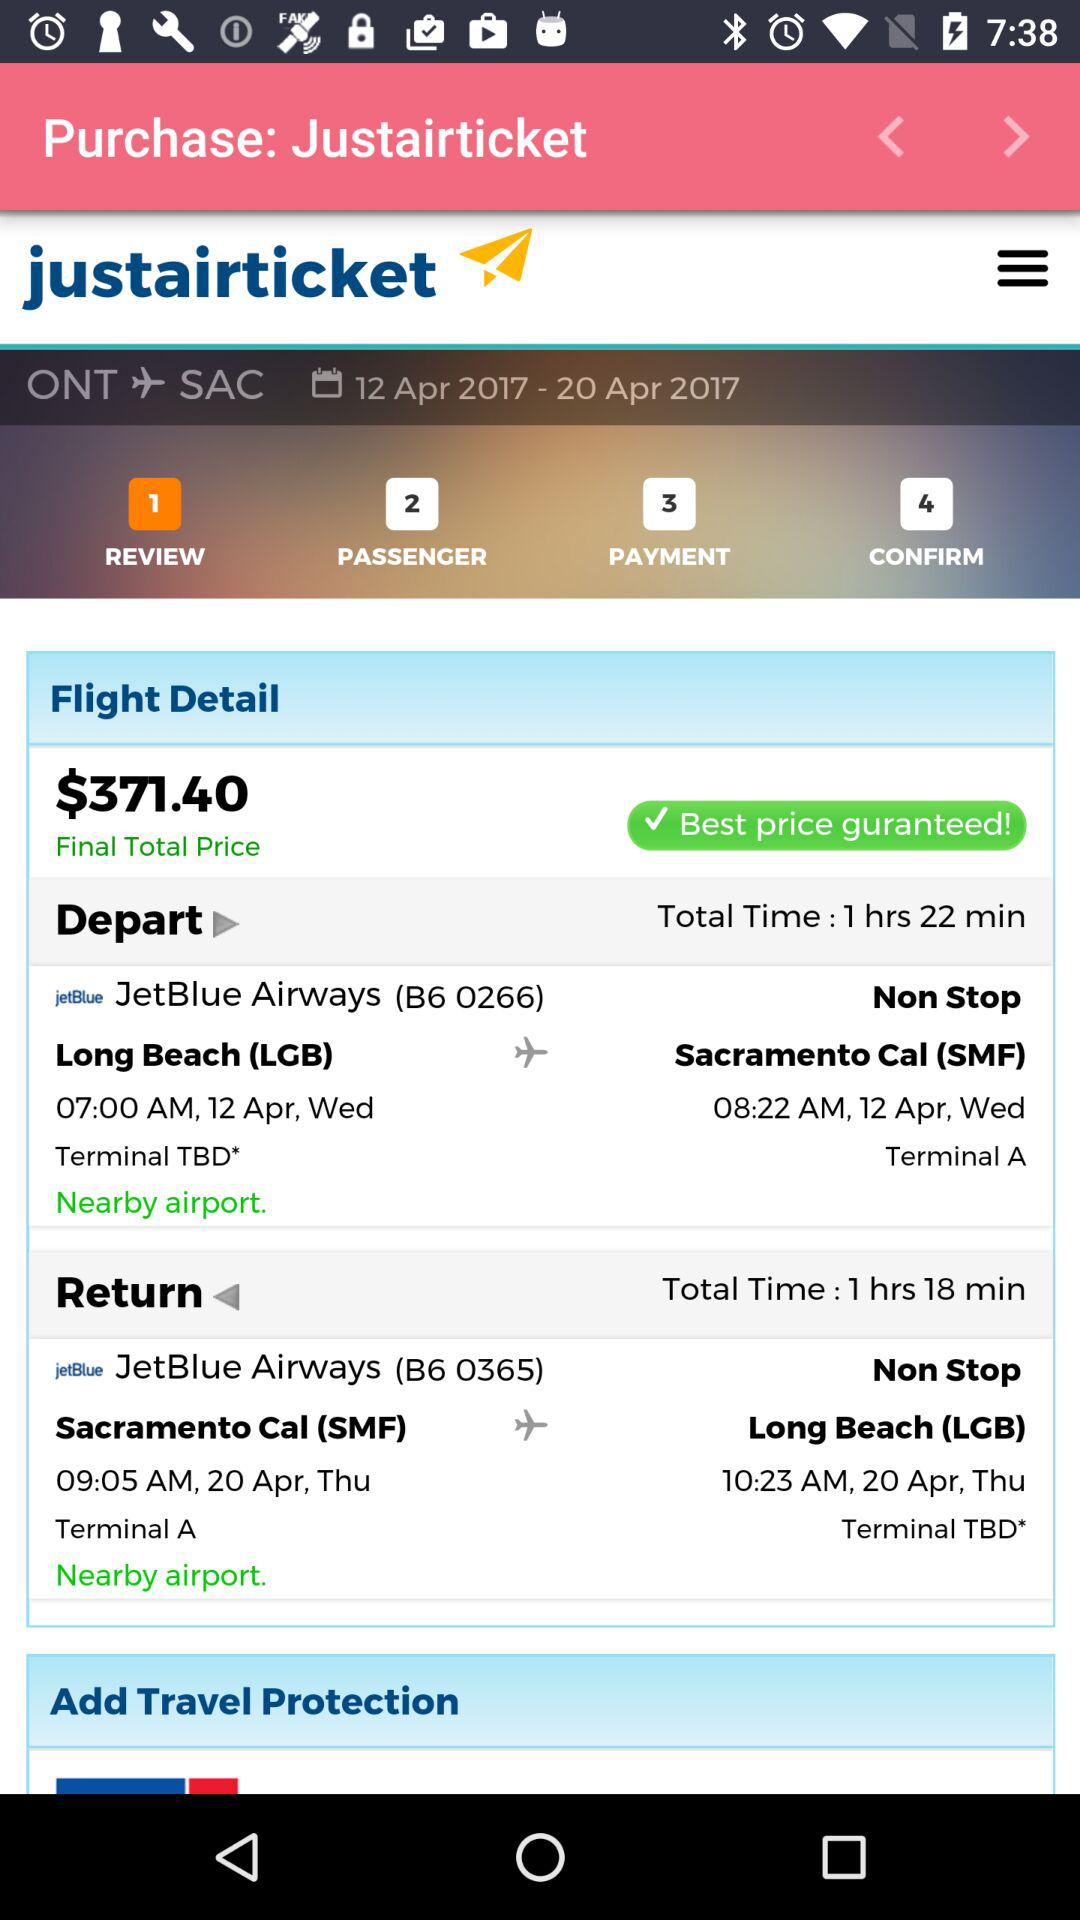What is the departure date for JetBlue Airways (B6 0266)? The date is Wednesday, April 12. 